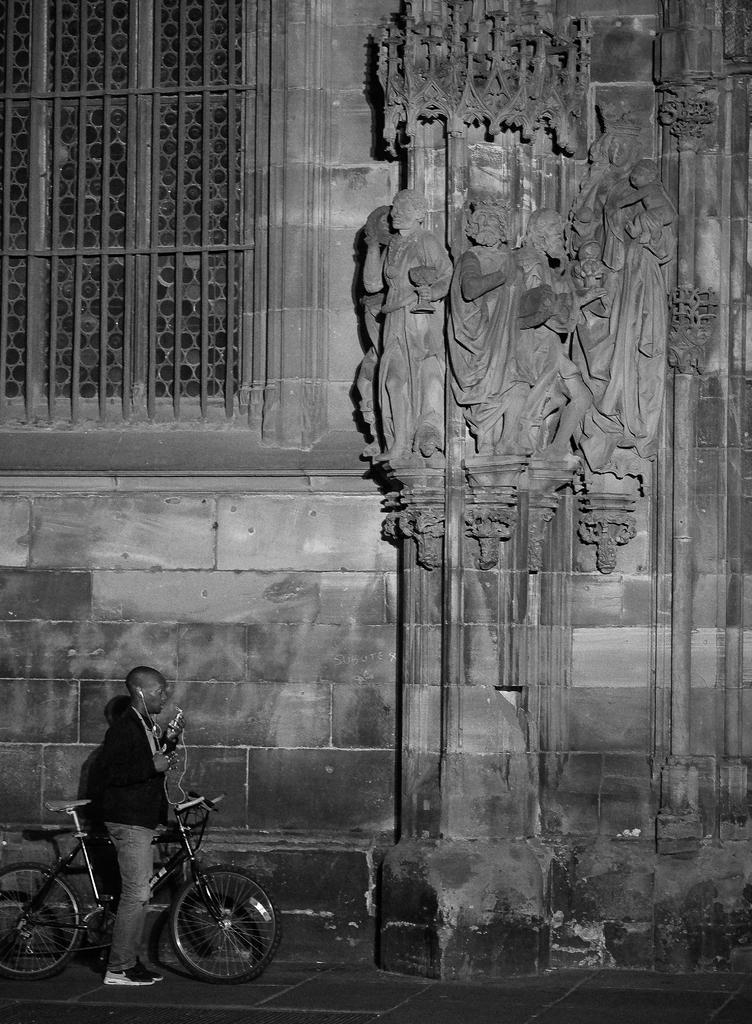In one or two sentences, can you explain what this image depicts? It is a black and white picture,a man is standing on a cycle,he is wearing headphones,beside him there is a big wall,to the wall there are giant sculptures,to the left side there is a big window. 